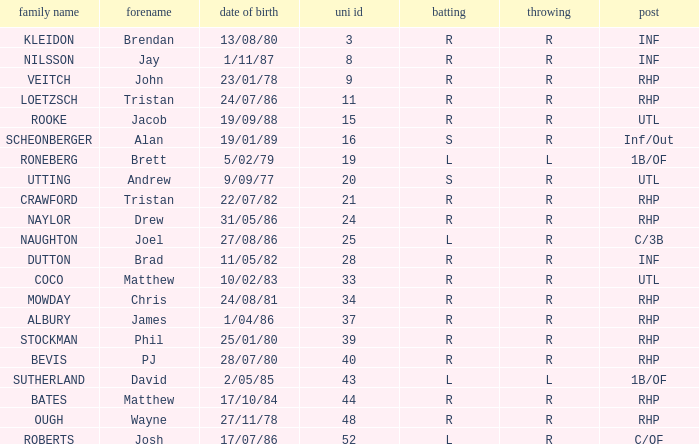How many Uni numbers have Bats of s, and a Position of utl? 1.0. 